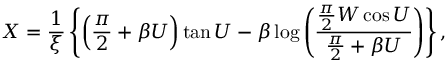<formula> <loc_0><loc_0><loc_500><loc_500>X = { \frac { 1 } { \xi } } \left \{ \left ( { \frac { \pi } { 2 } } + \beta U \right ) \tan U - \beta \log \left ( { \frac { { \frac { \pi } { 2 } } W \cos U } { { \frac { \pi } { 2 } } + \beta U } } \right ) \right \} ,</formula> 